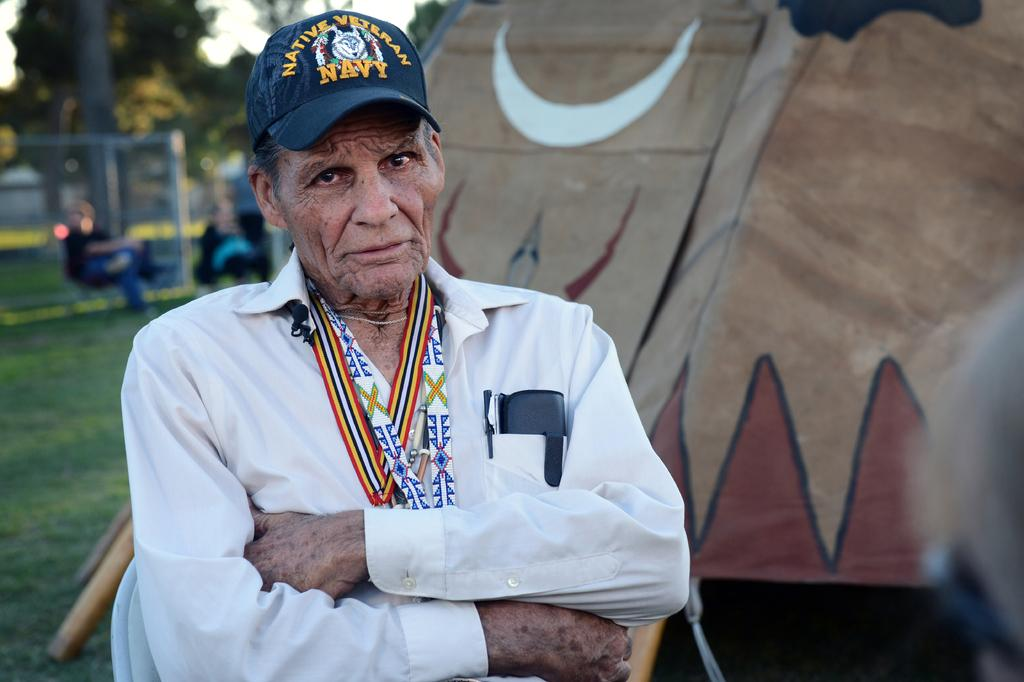Provide a one-sentence caption for the provided image. the old white shirted man standing with folding hands who wears the blue color cap printed as native veteran navy. 